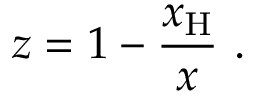Convert formula to latex. <formula><loc_0><loc_0><loc_500><loc_500>z = 1 - \frac { x _ { H } } { x } \ .</formula> 